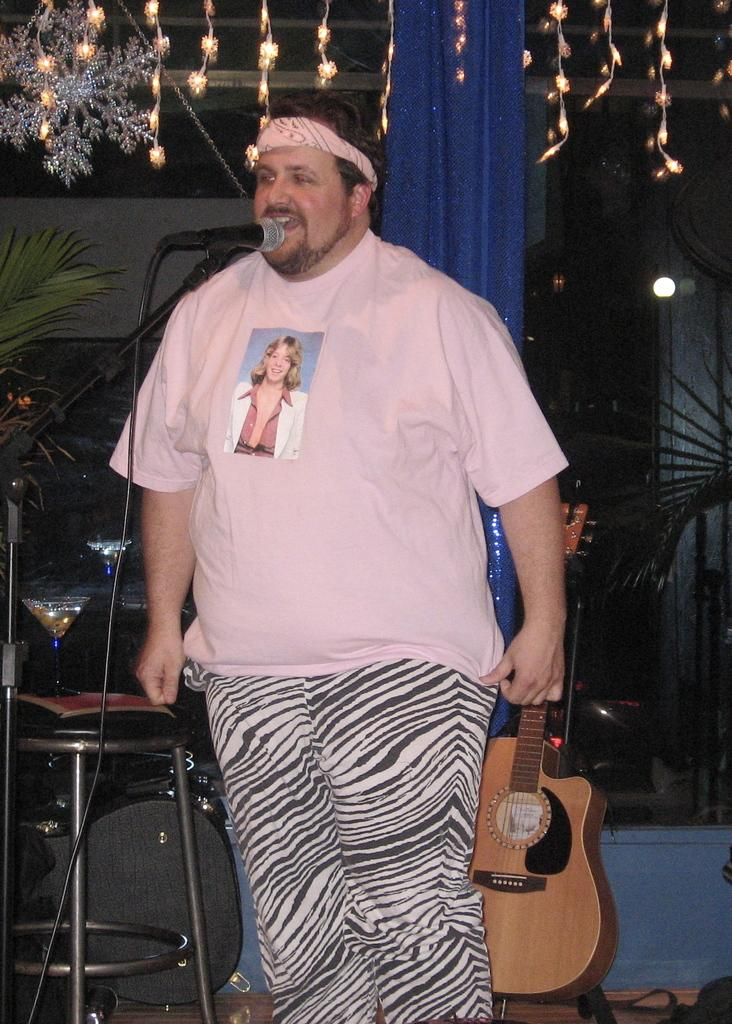What is the main subject of the image? The main subject of the image is a man. What is the man doing in the image? The man is standing in front of a mic. What can be seen in the background of the image? In the background of the image, there is a guitar, a stool, plants, and lights. What type of wealth can be seen in the image? There is no indication of wealth in the image; it features a man standing in front of a mic with a guitar, stool, plants, and lights in the background. Can you describe the garden in the image? There is no garden present in the image; it features a man standing in front of a mic with a guitar, stool, plants, and lights in the background. 